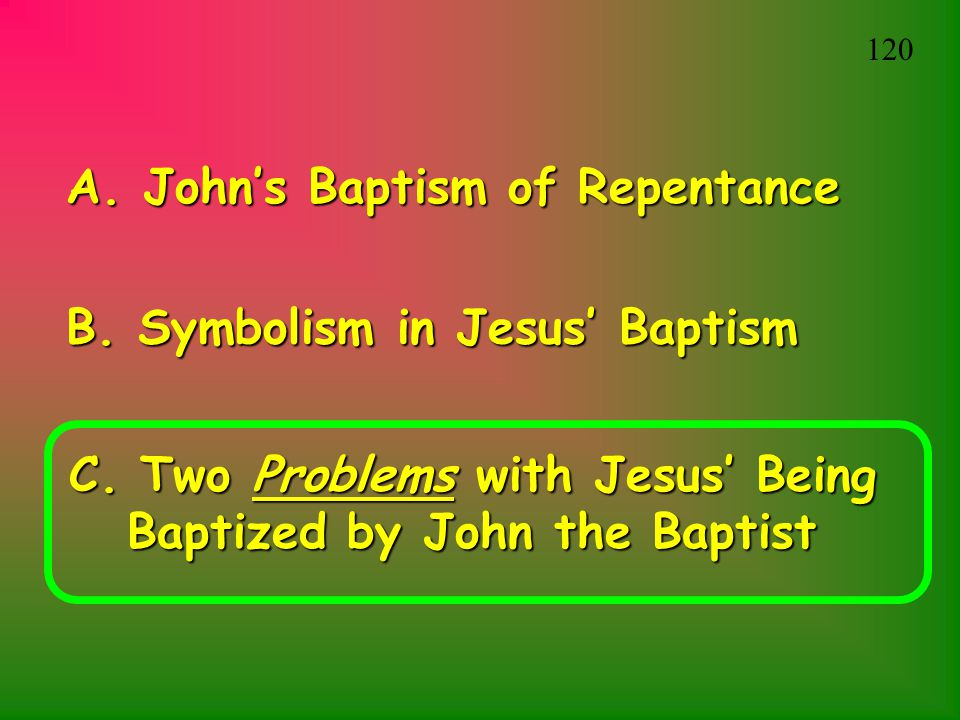What might the two problems referred to in the third bullet point be, given the context? Given the context, the two problems referred to in the third bullet point are likely theological issues surrounding Jesus' baptism by John the Baptist. The first problem may relate to the idea that Jesus, being sinless, would not need a baptism of repentance, which could create confusion about the nature of his sinlessness. The second problem may concern the perceived subordination of Jesus to John the Baptist through the act of baptism, which could challenge beliefs about Jesus' divine status and authority. These issues would be significant points of discussion within the theological framework of the presentation. Can you describe a realistic scenario where someone might confront these problems in a discussion? In a biblical studies seminar at a theological college, a student might present these problems during a debate on the significance of Jesus' baptism. The student could argue that Jesus' sinless nature makes his participation in a baptism of repentance unnecessary, challenging the traditional understanding. Another student might counter this by explaining that Jesus' baptism was a symbolic act of identifying with humanity and fulfilling all righteousness. The discussion could then shift to the implications of Jesus being baptized by John, with participants debating whether this act diminishes Jesus' divine authority or whether it exemplifies his humility and purpose. Such a scenario would allow for a rich exchange of interpretations and theological insights. How might an artist creatively portray the moment of Jesus' baptism by John, given the symbolic and theological weight of the event? An artist could creatively portray the moment of Jesus' baptism by John using a combination of visual symbolism and dynamic composition. They might depict the scene with John standing in the Jordan River, his hand outstretched in an act of baptism, while Jesus humbly bows his head. Above, the heavens could be opened, and a beam of divine light descends, representing the Holy Spirit in the form of a dove. Surrounding the main figures, the artist could illustrate elements of nature, perhaps with water ripples extending outward, symbolizing the far-reaching impact of this event. The background might feature a subtle mix of Old Testament imagery, such as a faint silhouette of the Ten Commandments or the burning bush, blending with New Testament symbols like a cross or fish, highlighting the continuity and fulfillment of Jesus' mission. The use of light and shadow, vibrant colors, and expressive details would convey the profound spiritual and theological significance of this moment. Create a very imaginative and detailed narrative that places the event of Jesus' baptism in a completely different context or setting. In a distant future where humanity has colonized Mars, the event of Jesus' baptism is reimagined in a breathtaking Martian landscape. The arid, red terrain is punctuated by the rare sight of liquid water—a crystal-clear oasis fed by an underground spring. In this vision, John the Baptist, dressed in a futuristic robe that blends traditional and modern elements, stands at the edge of the water. His staff, adorned with symbols of both earthly roots and celestial exploration, gleams under the twin suns of Mars. Jesus, wearing a robe that shimmers with a fabric reflecting the stars, approaches the oasis, his presence instilling a sense of peace and reverence among the colonists gathered around. The moment John baptizes Jesus, the water of the oasis begins to glow with a soft, otherworldly light, symbolizing purification not just for Earth, but for all humanity, transcending the boundaries of planets. Above, the sky parts, revealing a radiant constellation shaped like a dove, representing the Holy Spirit in this interplanetary setting. The Martian wind carries whispers of divine approval, and the colonists, moved by the sight, feel the profound interconnectedness of their faith, bridging the ancient with the futuristic, the earthly with the cosmic. 